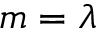Convert formula to latex. <formula><loc_0><loc_0><loc_500><loc_500>m = \lambda</formula> 